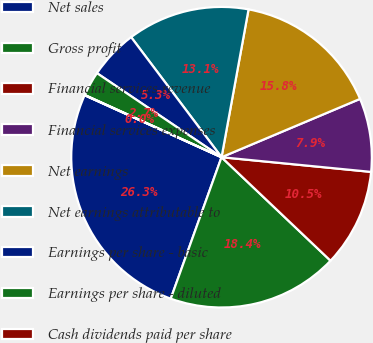<chart> <loc_0><loc_0><loc_500><loc_500><pie_chart><fcel>Net sales<fcel>Gross profit<fcel>Financial services revenue<fcel>Financial services expenses<fcel>Net earnings<fcel>Net earnings attributable to<fcel>Earnings per share - basic<fcel>Earnings per share - diluted<fcel>Cash dividends paid per share<nl><fcel>26.28%<fcel>18.4%<fcel>10.53%<fcel>7.9%<fcel>15.78%<fcel>13.15%<fcel>5.28%<fcel>2.65%<fcel>0.03%<nl></chart> 